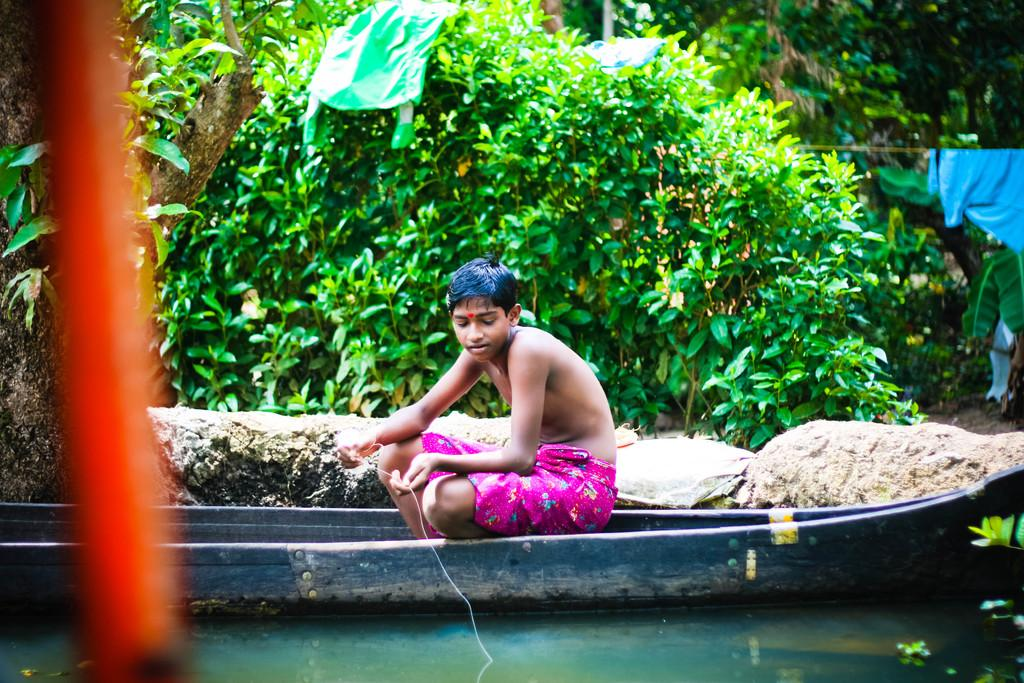Who is the main subject in the image? There is a boy in the image. What is the boy doing in the image? The boy is sitting on a boat. Where is the boat located in the image? The boat is on the water. What other natural elements can be seen in the image? There are rocks and trees visible in the image. What else is present in the image besides the boy and the boat? There are clothes visible in the image. What type of bone is visible in the image? There is no bone present in the image; it features a boy sitting on a boat on the water, surrounded by rocks, trees, and clothes. 